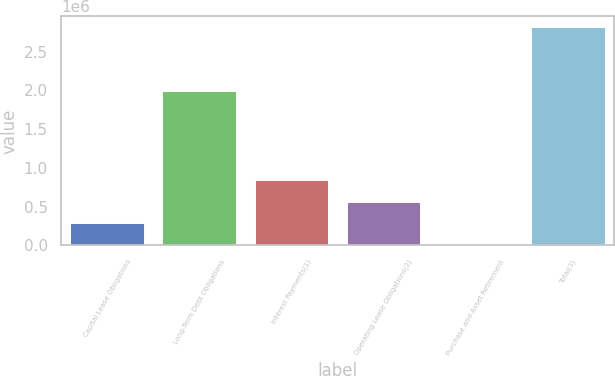Convert chart. <chart><loc_0><loc_0><loc_500><loc_500><bar_chart><fcel>Capital Lease Obligations<fcel>Long-Term Debt Obligations<fcel>Interest Payments(1)<fcel>Operating Lease Obligations(2)<fcel>Purchase and Asset Retirement<fcel>Total(3)<nl><fcel>284524<fcel>1.9929e+06<fcel>846050<fcel>565287<fcel>3762<fcel>2.81139e+06<nl></chart> 